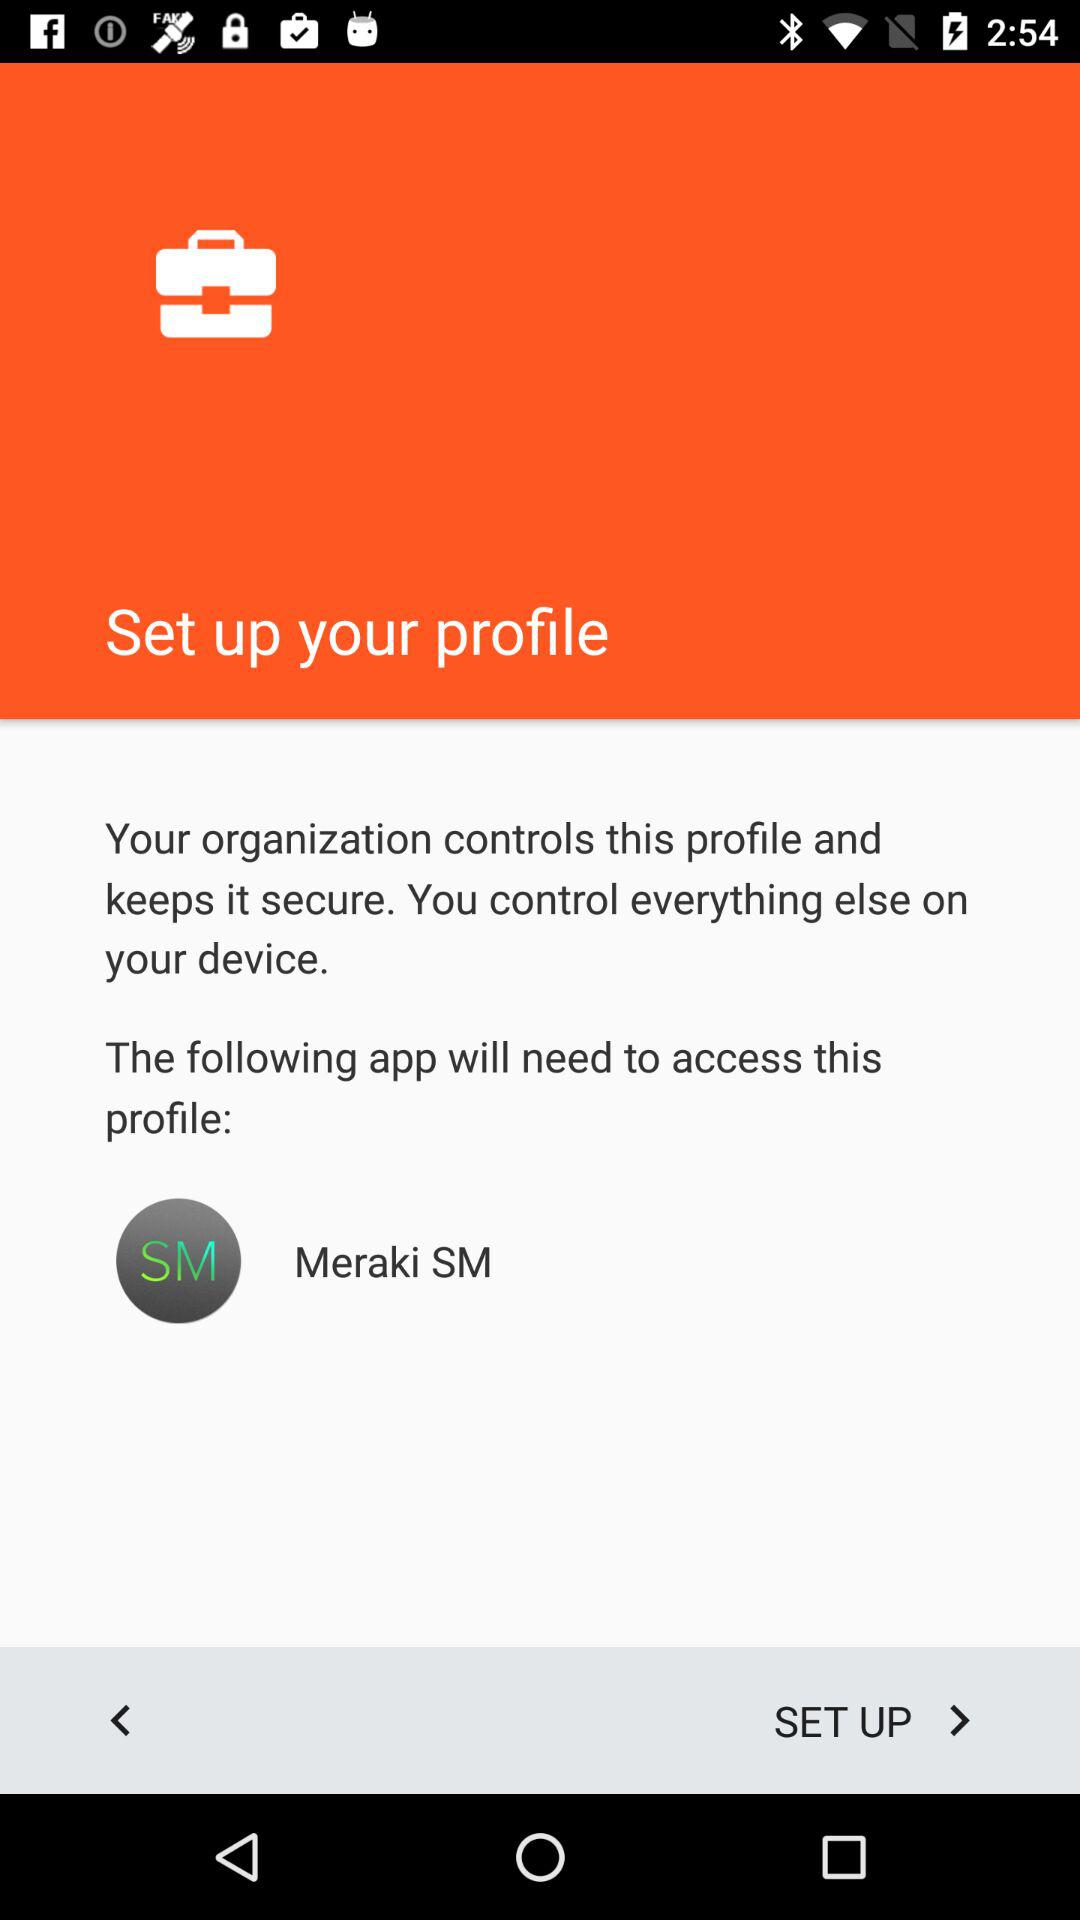Which profile did the following application will access?
When the provided information is insufficient, respond with <no answer>. <no answer> 